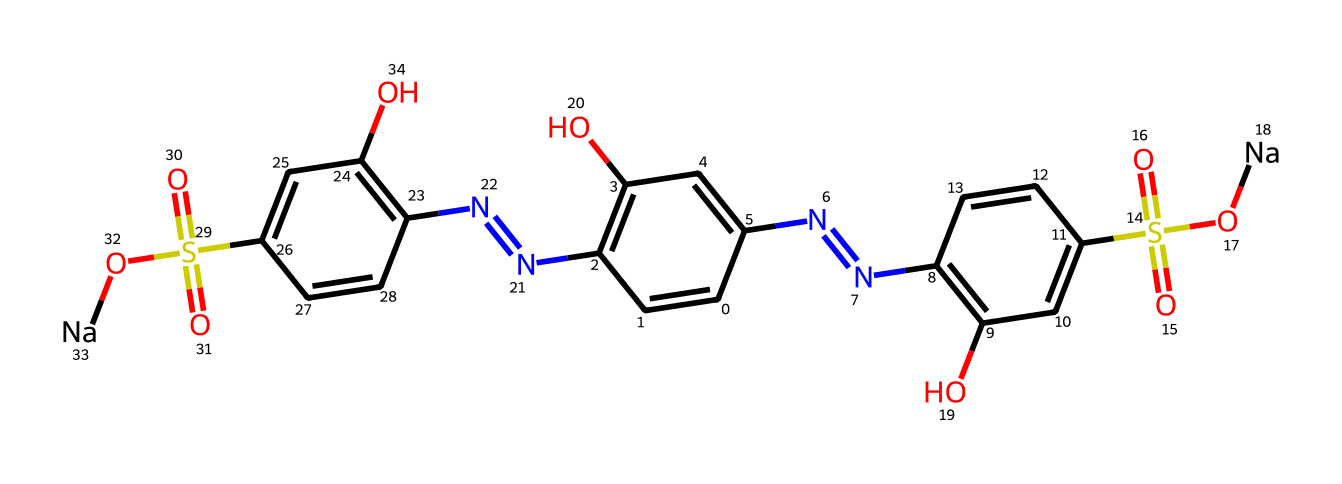What is the total number of carbon atoms in this compound? By analyzing the SMILES representation, we identify the carbon atoms represented by the letter 'C'. Counting all instances of 'C', both in the ring structures and side chains, we find a total of 18 carbon atoms.
Answer: 18 How many nitrogen atoms are present? The presence of nitrogen atoms is indicated by the letter 'N' in the SMILES notation. We can count four occurrences of 'N', which indicates that there are four nitrogen atoms in the compound.
Answer: 4 What type of chemical is this primarily classified as? Given the structure and the presence of multiple aromatic rings along with sulfonic acid groups, this compound is classified as a synthetic dye or food additive.
Answer: synthetic dye What functional groups are indicated in the structure? Upon inspecting the SMILES, several functional groups are present: the sulfonic acid group (-S(=O)(=O)O) and hydroxyl groups (-OH) attached to the aromatic rings. These groups contribute to the compound's solubility and color properties.
Answer: sulfonic acid and hydroxyl groups How many hydroxyl (-OH) groups can you identify? By evaluating the SMILES representation, we notice there are two distinct -OH groups attached to the aromatic rings. Therefore, we can conclude there are two hydroxyl groups in the structure.
Answer: 2 Does this compound contain any acidic groups? The presence of the sulfonic acid (-S(=O)(=O)O) indicates that this compound has acidic properties because the sulfonic acid group can donate protons in solution.
Answer: Yes 